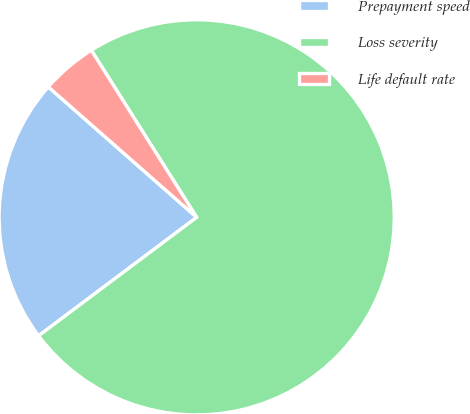Convert chart. <chart><loc_0><loc_0><loc_500><loc_500><pie_chart><fcel>Prepayment speed<fcel>Loss severity<fcel>Life default rate<nl><fcel>21.71%<fcel>73.71%<fcel>4.57%<nl></chart> 